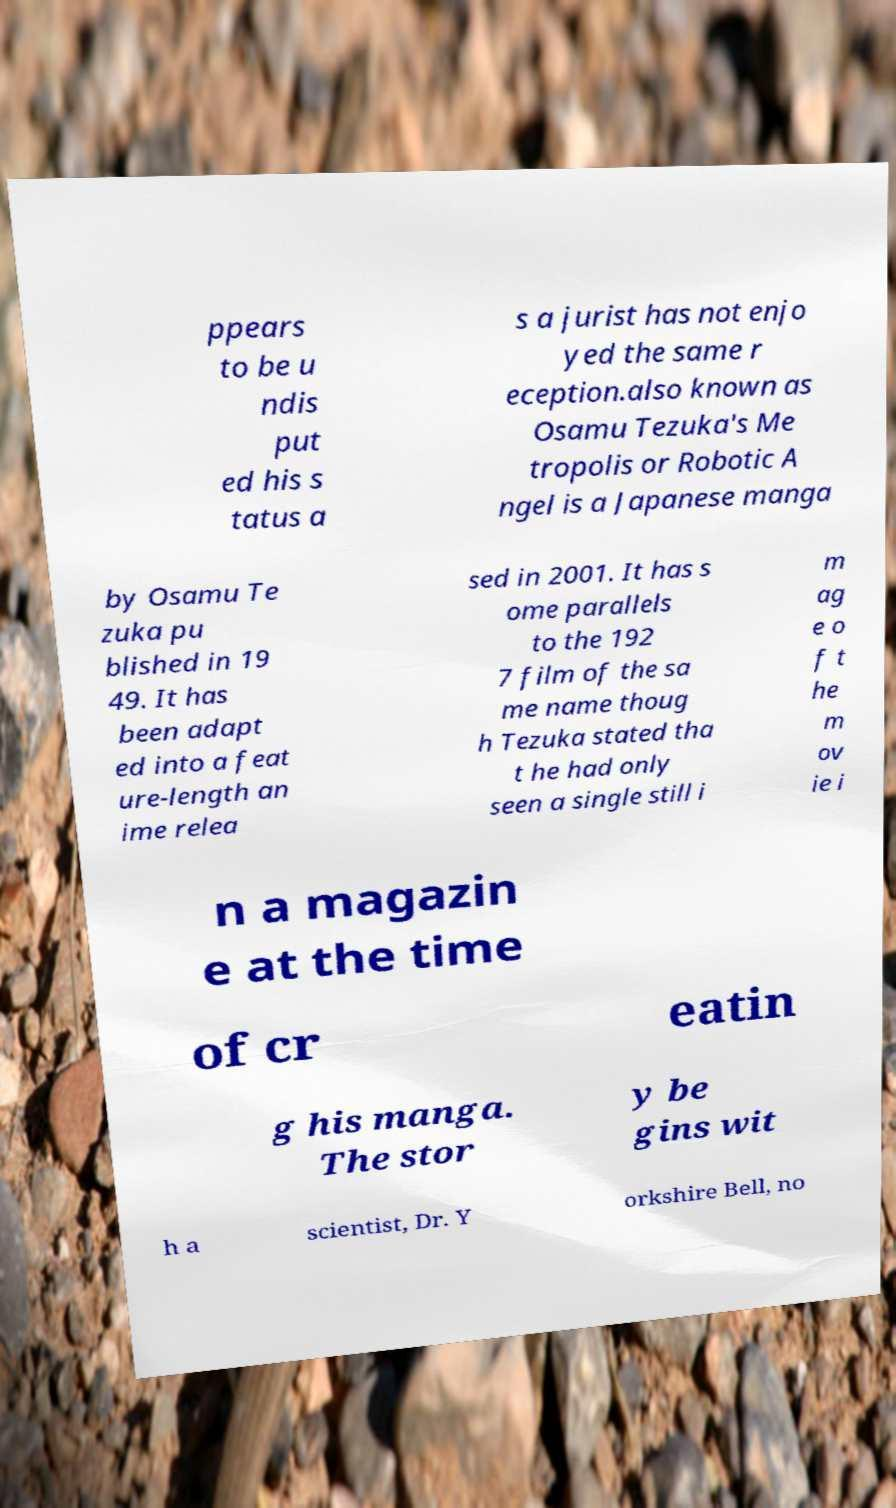Could you extract and type out the text from this image? ppears to be u ndis put ed his s tatus a s a jurist has not enjo yed the same r eception.also known as Osamu Tezuka's Me tropolis or Robotic A ngel is a Japanese manga by Osamu Te zuka pu blished in 19 49. It has been adapt ed into a feat ure-length an ime relea sed in 2001. It has s ome parallels to the 192 7 film of the sa me name thoug h Tezuka stated tha t he had only seen a single still i m ag e o f t he m ov ie i n a magazin e at the time of cr eatin g his manga. The stor y be gins wit h a scientist, Dr. Y orkshire Bell, no 